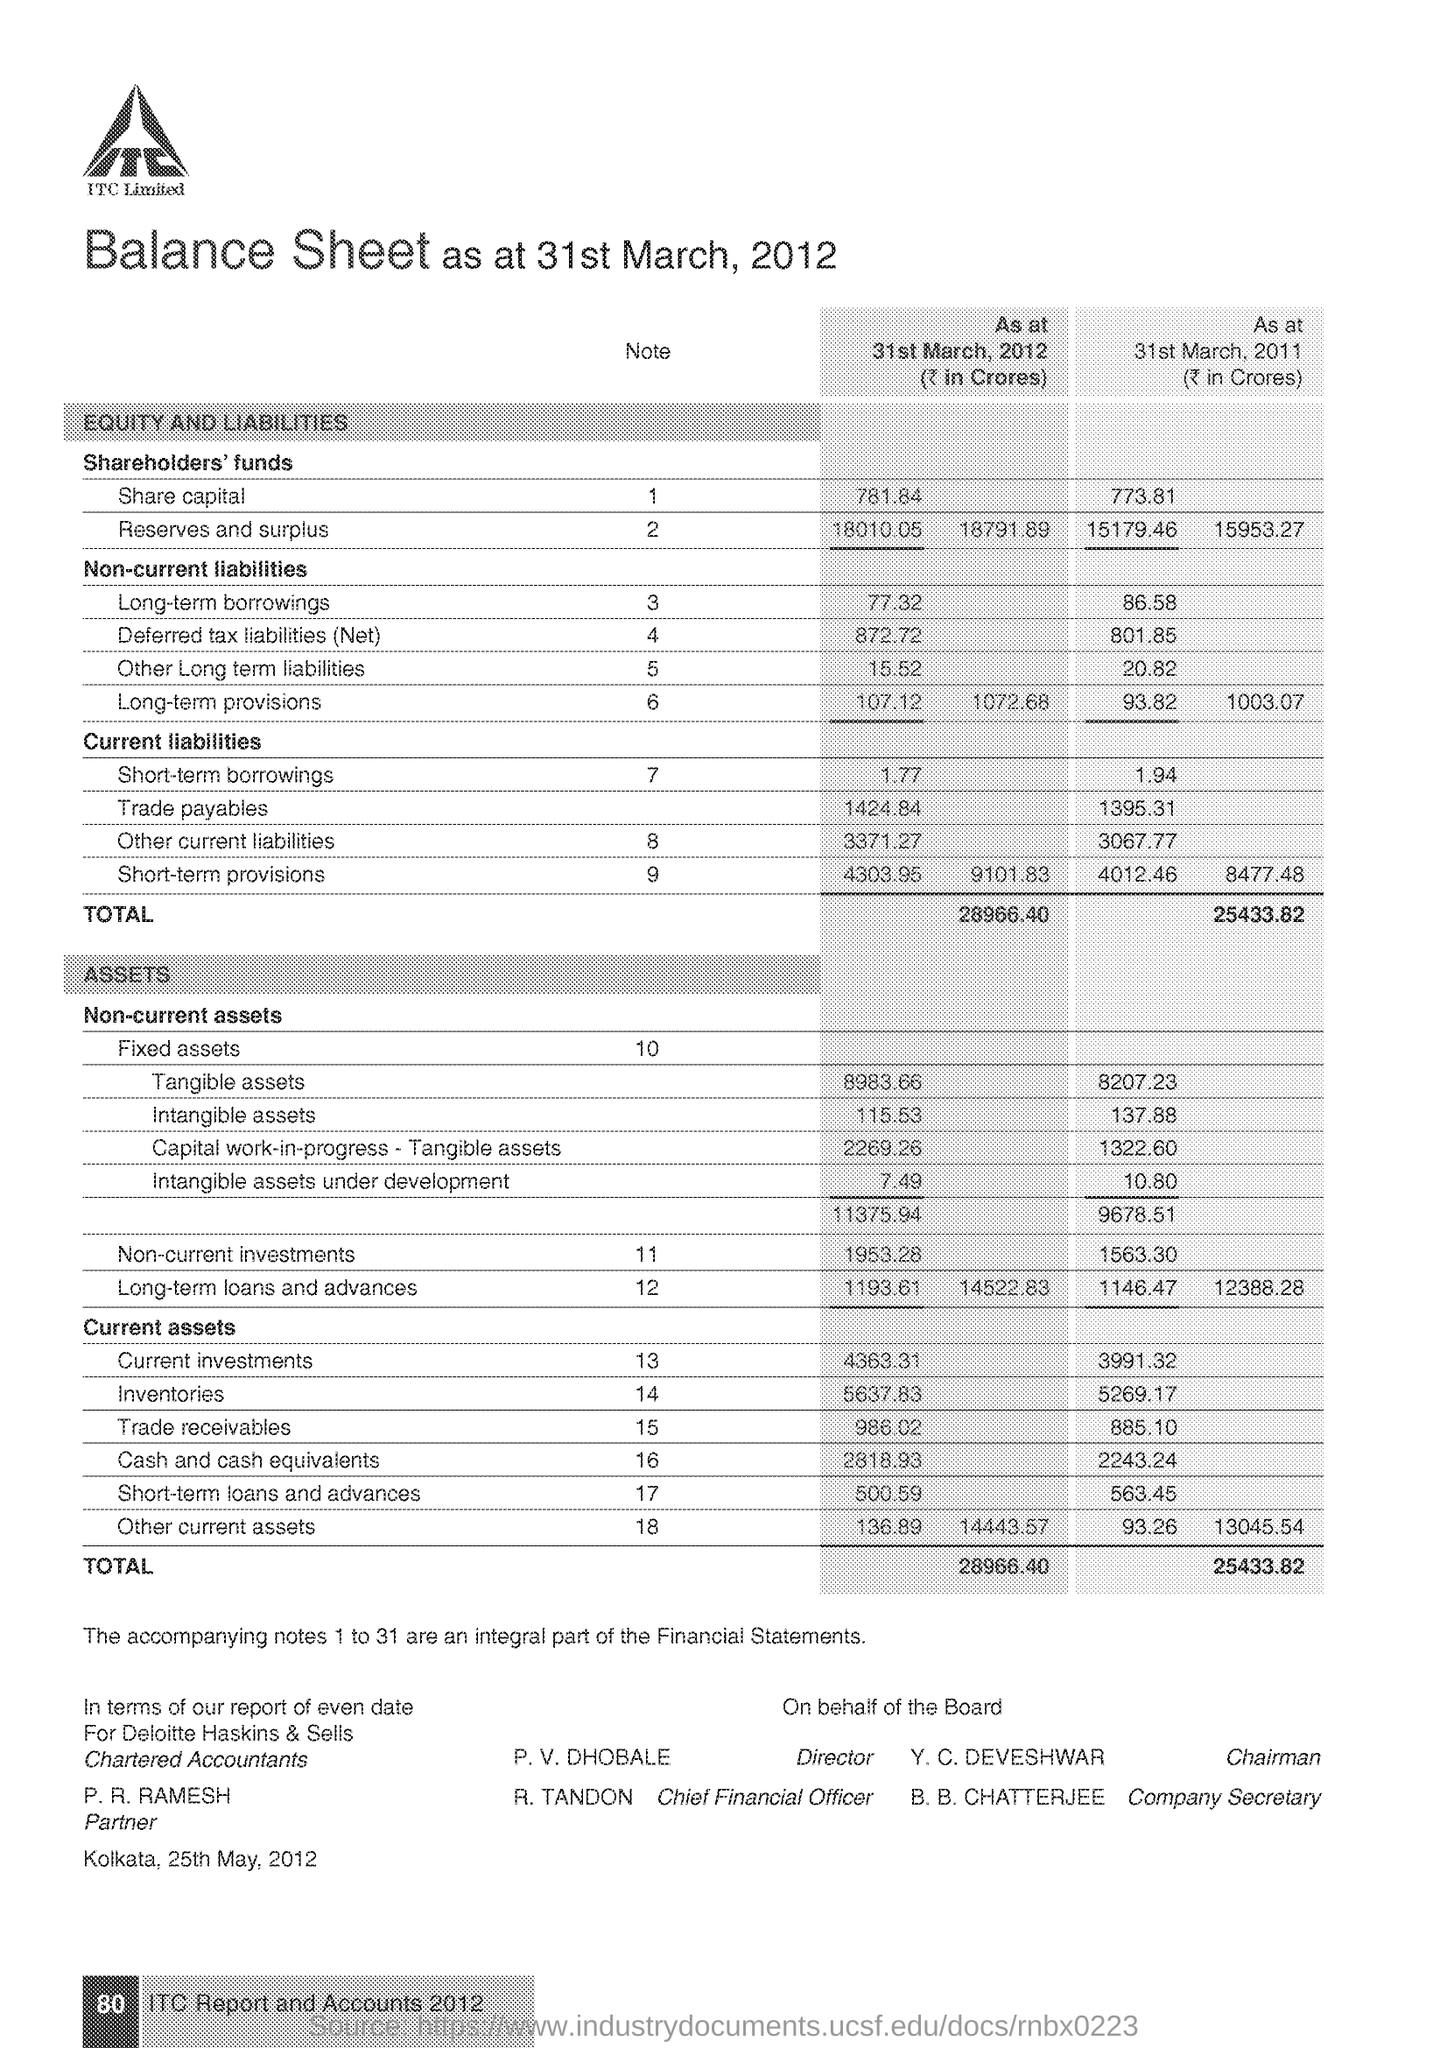How much Share capital  in 2012 ?
Provide a short and direct response. 781.84. What is the Note number for Reserves and Surplus ?
Make the answer very short. 2. Who is the Chairman ?
Make the answer very short. Y. C. DEVESHWAR. What is the Fixed Asset note number ?
Your response must be concise. 10. Who is the Director ?
Offer a very short reply. P. V. DHOBALE. How much Trade Payables in 2011?
Provide a short and direct response. 1395.31. Who is the Company Secretary ?
Provide a succinct answer. B. b. chatterjee. Who is the Cheif Financial Officer ?
Your response must be concise. R. tandon. How much Intangible assets in 2012 ?
Provide a succinct answer. 115.53. 